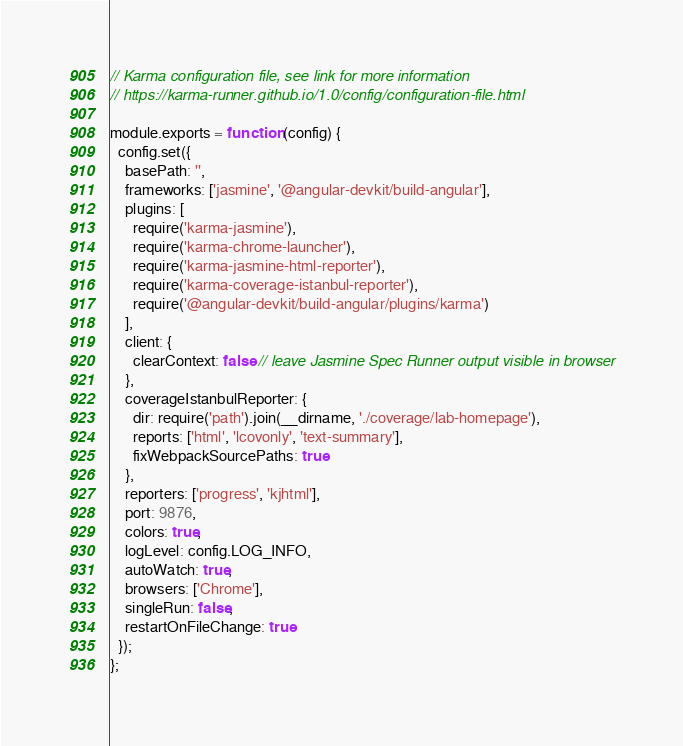<code> <loc_0><loc_0><loc_500><loc_500><_JavaScript_>// Karma configuration file, see link for more information
// https://karma-runner.github.io/1.0/config/configuration-file.html

module.exports = function (config) {
  config.set({
    basePath: '',
    frameworks: ['jasmine', '@angular-devkit/build-angular'],
    plugins: [
      require('karma-jasmine'),
      require('karma-chrome-launcher'),
      require('karma-jasmine-html-reporter'),
      require('karma-coverage-istanbul-reporter'),
      require('@angular-devkit/build-angular/plugins/karma')
    ],
    client: {
      clearContext: false // leave Jasmine Spec Runner output visible in browser
    },
    coverageIstanbulReporter: {
      dir: require('path').join(__dirname, './coverage/lab-homepage'),
      reports: ['html', 'lcovonly', 'text-summary'],
      fixWebpackSourcePaths: true
    },
    reporters: ['progress', 'kjhtml'],
    port: 9876,
    colors: true,
    logLevel: config.LOG_INFO,
    autoWatch: true,
    browsers: ['Chrome'],
    singleRun: false,
    restartOnFileChange: true
  });
};
</code> 